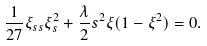Convert formula to latex. <formula><loc_0><loc_0><loc_500><loc_500>\frac { 1 } { 2 7 } \xi _ { s s } \xi _ { s } ^ { 2 } + \frac { \lambda } { 2 } s ^ { 2 } \xi ( 1 - \xi ^ { 2 } ) = 0 .</formula> 